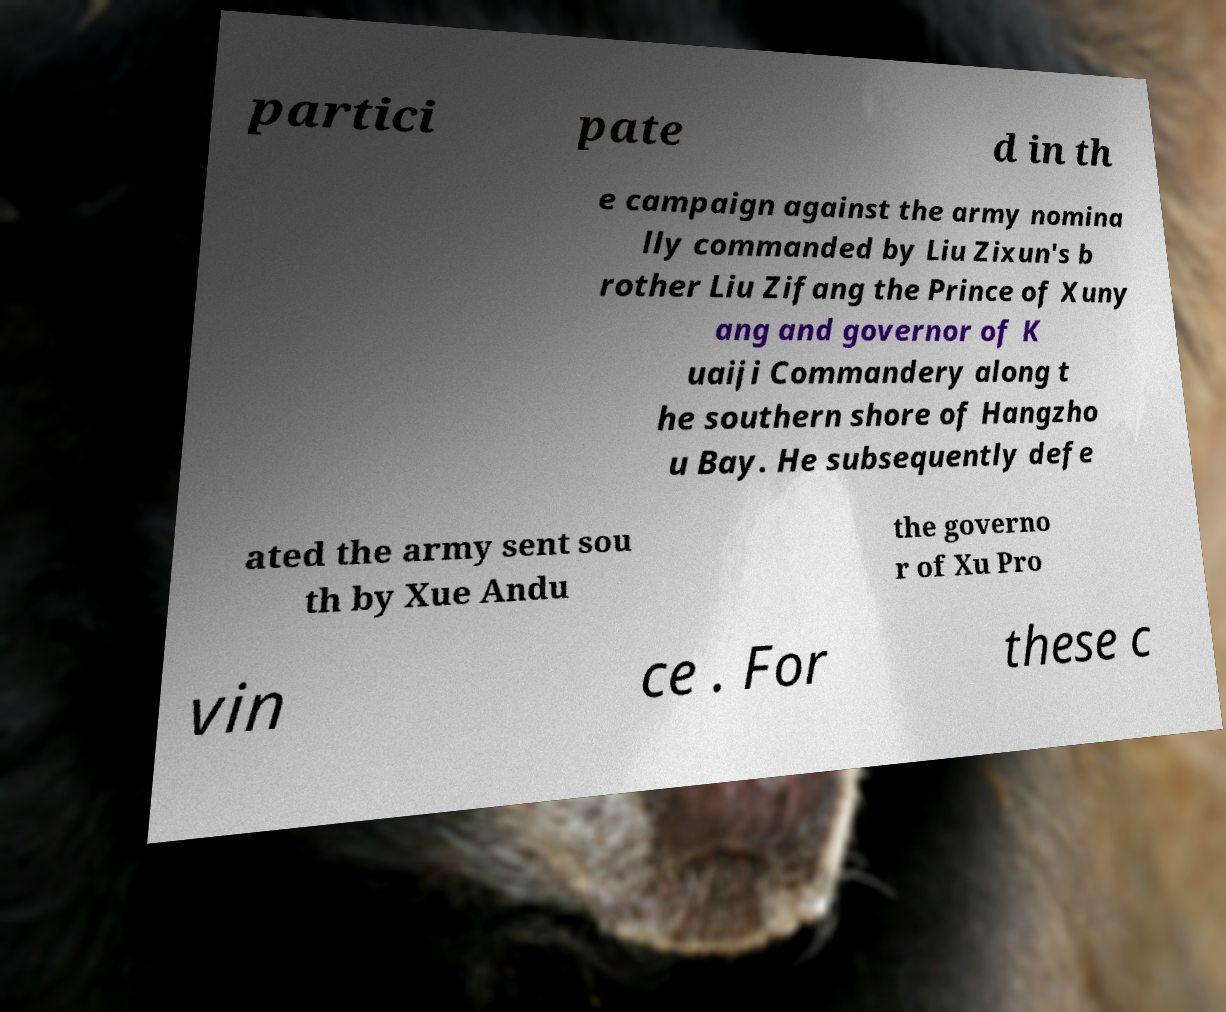There's text embedded in this image that I need extracted. Can you transcribe it verbatim? partici pate d in th e campaign against the army nomina lly commanded by Liu Zixun's b rother Liu Zifang the Prince of Xuny ang and governor of K uaiji Commandery along t he southern shore of Hangzho u Bay. He subsequently defe ated the army sent sou th by Xue Andu the governo r of Xu Pro vin ce . For these c 